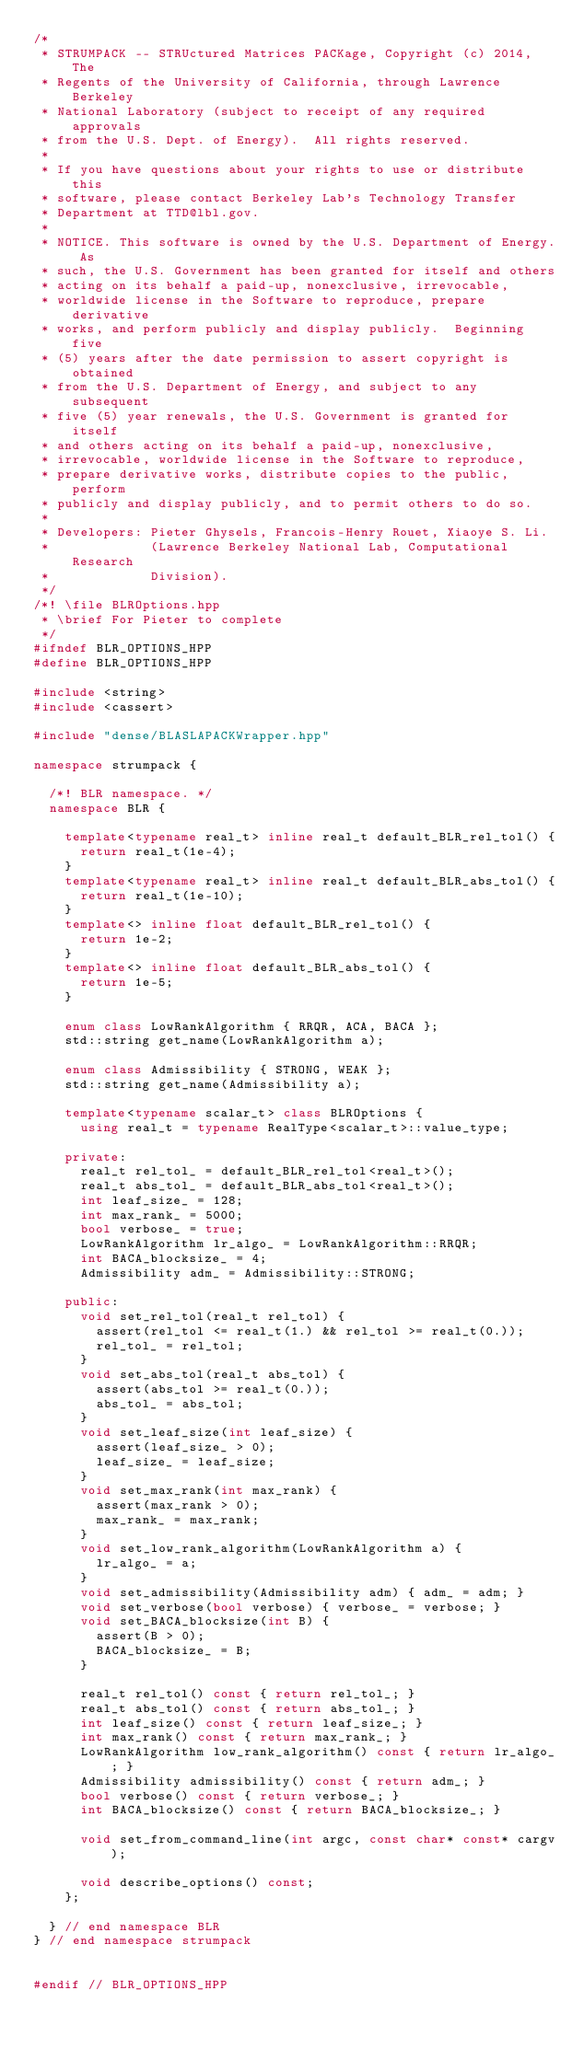<code> <loc_0><loc_0><loc_500><loc_500><_C++_>/*
 * STRUMPACK -- STRUctured Matrices PACKage, Copyright (c) 2014, The
 * Regents of the University of California, through Lawrence Berkeley
 * National Laboratory (subject to receipt of any required approvals
 * from the U.S. Dept. of Energy).  All rights reserved.
 *
 * If you have questions about your rights to use or distribute this
 * software, please contact Berkeley Lab's Technology Transfer
 * Department at TTD@lbl.gov.
 *
 * NOTICE. This software is owned by the U.S. Department of Energy. As
 * such, the U.S. Government has been granted for itself and others
 * acting on its behalf a paid-up, nonexclusive, irrevocable,
 * worldwide license in the Software to reproduce, prepare derivative
 * works, and perform publicly and display publicly.  Beginning five
 * (5) years after the date permission to assert copyright is obtained
 * from the U.S. Department of Energy, and subject to any subsequent
 * five (5) year renewals, the U.S. Government is granted for itself
 * and others acting on its behalf a paid-up, nonexclusive,
 * irrevocable, worldwide license in the Software to reproduce,
 * prepare derivative works, distribute copies to the public, perform
 * publicly and display publicly, and to permit others to do so.
 *
 * Developers: Pieter Ghysels, Francois-Henry Rouet, Xiaoye S. Li.
 *             (Lawrence Berkeley National Lab, Computational Research
 *             Division).
 */
/*! \file BLROptions.hpp
 * \brief For Pieter to complete
 */
#ifndef BLR_OPTIONS_HPP
#define BLR_OPTIONS_HPP

#include <string>
#include <cassert>

#include "dense/BLASLAPACKWrapper.hpp"

namespace strumpack {

  /*! BLR namespace. */
  namespace BLR {

    template<typename real_t> inline real_t default_BLR_rel_tol() {
      return real_t(1e-4);
    }
    template<typename real_t> inline real_t default_BLR_abs_tol() {
      return real_t(1e-10);
    }
    template<> inline float default_BLR_rel_tol() {
      return 1e-2;
    }
    template<> inline float default_BLR_abs_tol() {
      return 1e-5;
    }

    enum class LowRankAlgorithm { RRQR, ACA, BACA };
    std::string get_name(LowRankAlgorithm a);

    enum class Admissibility { STRONG, WEAK };
    std::string get_name(Admissibility a);

    template<typename scalar_t> class BLROptions {
      using real_t = typename RealType<scalar_t>::value_type;

    private:
      real_t rel_tol_ = default_BLR_rel_tol<real_t>();
      real_t abs_tol_ = default_BLR_abs_tol<real_t>();
      int leaf_size_ = 128;
      int max_rank_ = 5000;
      bool verbose_ = true;
      LowRankAlgorithm lr_algo_ = LowRankAlgorithm::RRQR;
      int BACA_blocksize_ = 4;
      Admissibility adm_ = Admissibility::STRONG;

    public:
      void set_rel_tol(real_t rel_tol) {
        assert(rel_tol <= real_t(1.) && rel_tol >= real_t(0.));
        rel_tol_ = rel_tol;
      }
      void set_abs_tol(real_t abs_tol) {
        assert(abs_tol >= real_t(0.));
        abs_tol_ = abs_tol;
      }
      void set_leaf_size(int leaf_size) {
        assert(leaf_size_ > 0);
        leaf_size_ = leaf_size;
      }
      void set_max_rank(int max_rank) {
        assert(max_rank > 0);
        max_rank_ = max_rank;
      }
      void set_low_rank_algorithm(LowRankAlgorithm a) {
        lr_algo_ = a;
      }
      void set_admissibility(Admissibility adm) { adm_ = adm; }
      void set_verbose(bool verbose) { verbose_ = verbose; }
      void set_BACA_blocksize(int B) {
        assert(B > 0);
        BACA_blocksize_ = B;
      }

      real_t rel_tol() const { return rel_tol_; }
      real_t abs_tol() const { return abs_tol_; }
      int leaf_size() const { return leaf_size_; }
      int max_rank() const { return max_rank_; }
      LowRankAlgorithm low_rank_algorithm() const { return lr_algo_; }
      Admissibility admissibility() const { return adm_; }
      bool verbose() const { return verbose_; }
      int BACA_blocksize() const { return BACA_blocksize_; }

      void set_from_command_line(int argc, const char* const* cargv);

      void describe_options() const;
    };

  } // end namespace BLR
} // end namespace strumpack


#endif // BLR_OPTIONS_HPP
</code> 